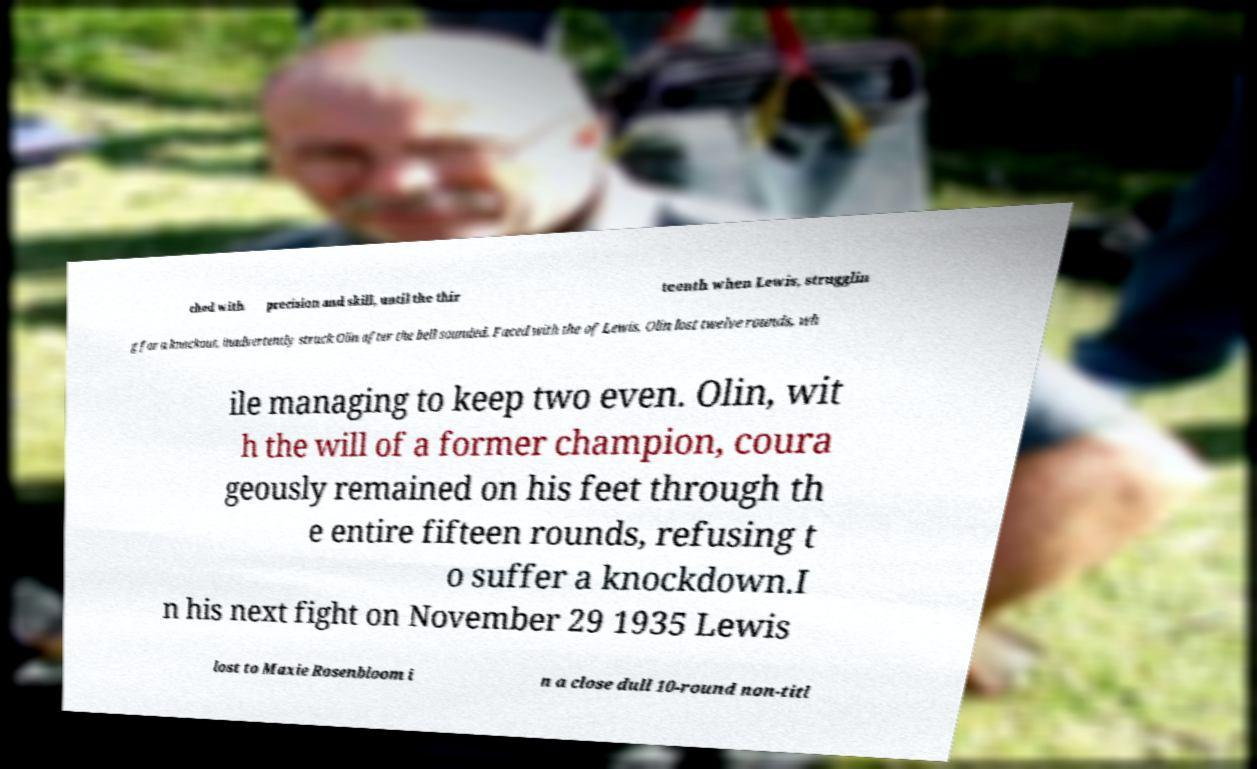Could you assist in decoding the text presented in this image and type it out clearly? ched with precision and skill, until the thir teenth when Lewis, strugglin g for a knockout, inadvertently struck Olin after the bell sounded. Faced with the of Lewis, Olin lost twelve rounds, wh ile managing to keep two even. Olin, wit h the will of a former champion, coura geously remained on his feet through th e entire fifteen rounds, refusing t o suffer a knockdown.I n his next fight on November 29 1935 Lewis lost to Maxie Rosenbloom i n a close dull 10-round non-titl 